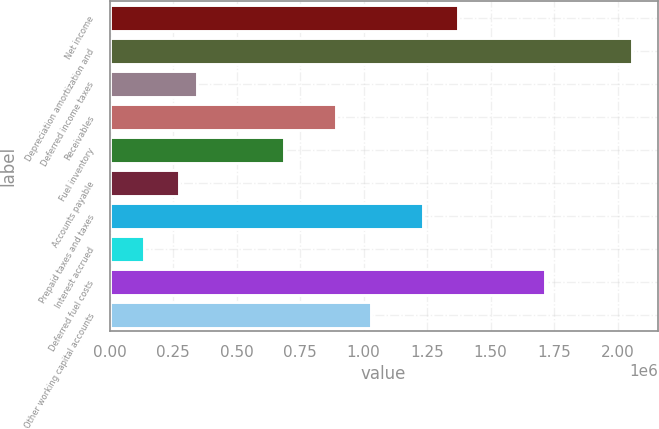Convert chart to OTSL. <chart><loc_0><loc_0><loc_500><loc_500><bar_chart><fcel>Net income<fcel>Depreciation amortization and<fcel>Deferred income taxes<fcel>Receivables<fcel>Fuel inventory<fcel>Accounts payable<fcel>Prepaid taxes and taxes<fcel>Interest accrued<fcel>Deferred fuel costs<fcel>Other working capital accounts<nl><fcel>1.37044e+06<fcel>2.05561e+06<fcel>342691<fcel>890824<fcel>685274<fcel>274174<fcel>1.23341e+06<fcel>137141<fcel>1.71302e+06<fcel>1.02786e+06<nl></chart> 